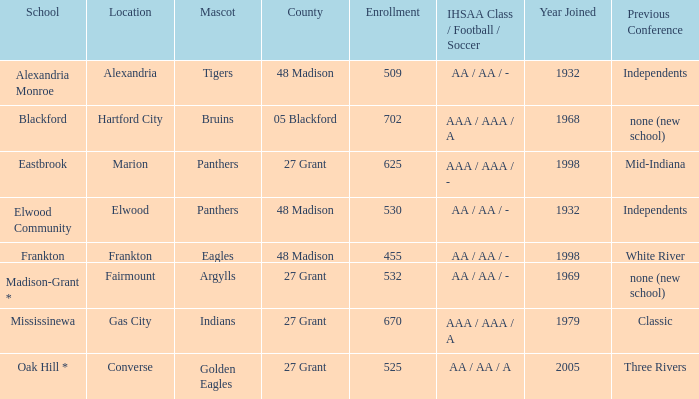What is teh ihsaa class/football/soccer when the location is alexandria? AA / AA / -. 